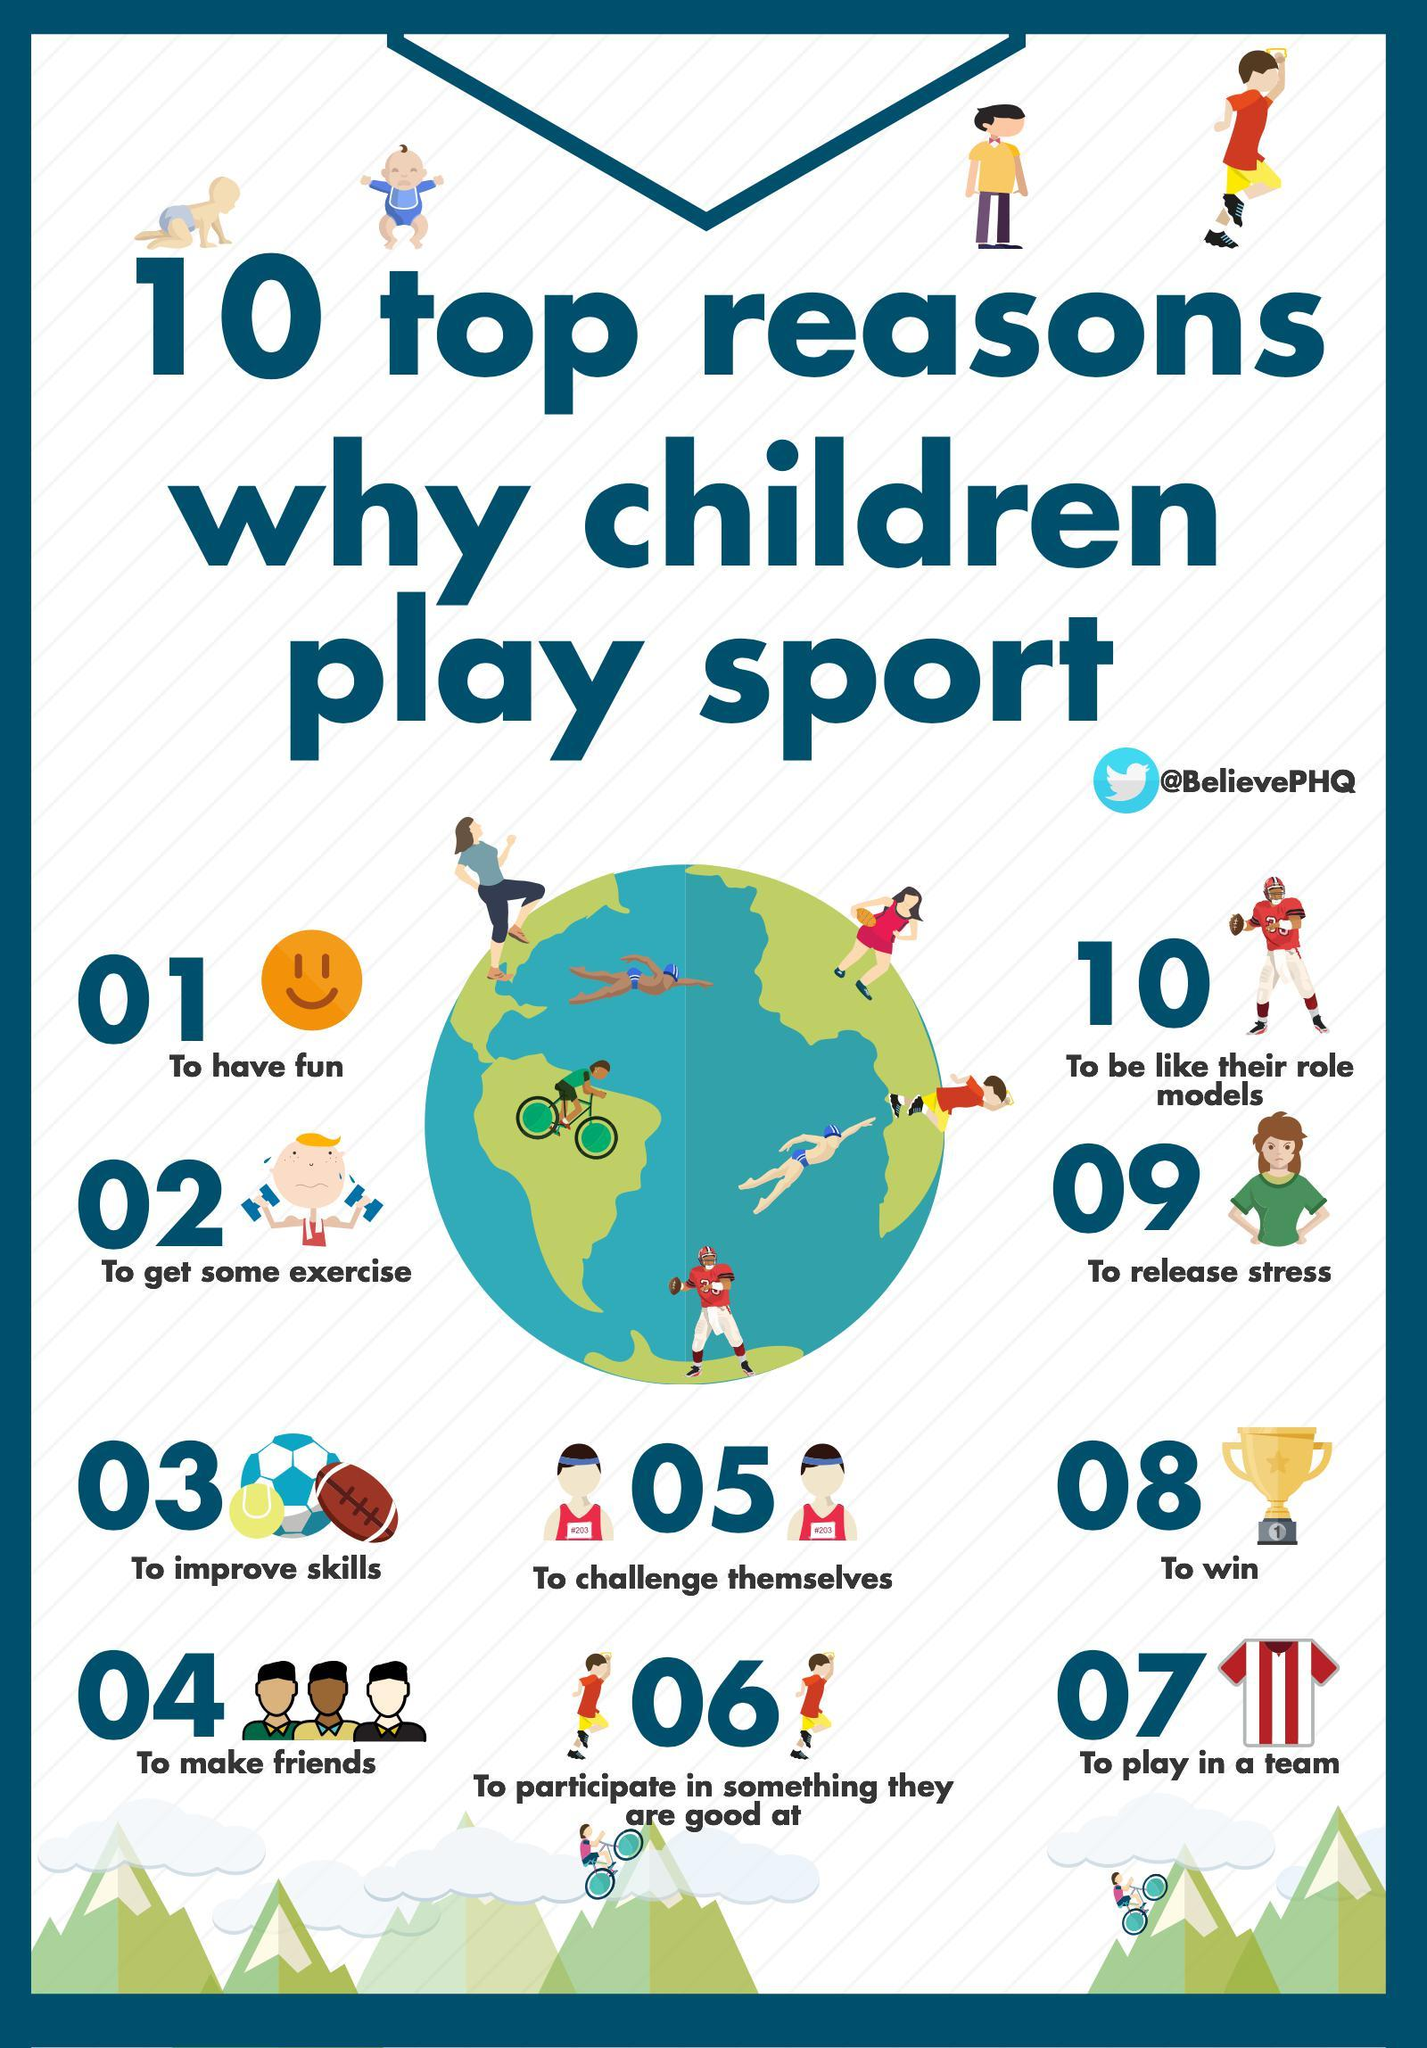Give some essential details in this illustration. Playing a musical instrument can help reduce tension. The question is, which position does playing help reduce tension the most? It appears to be the ninth, sixth, or second position. However, the answer is not clear. Playing as a team is the seventh reason why I enjoy playing. Children love to play because it allows them to win and experience the thrill of accomplishment. 